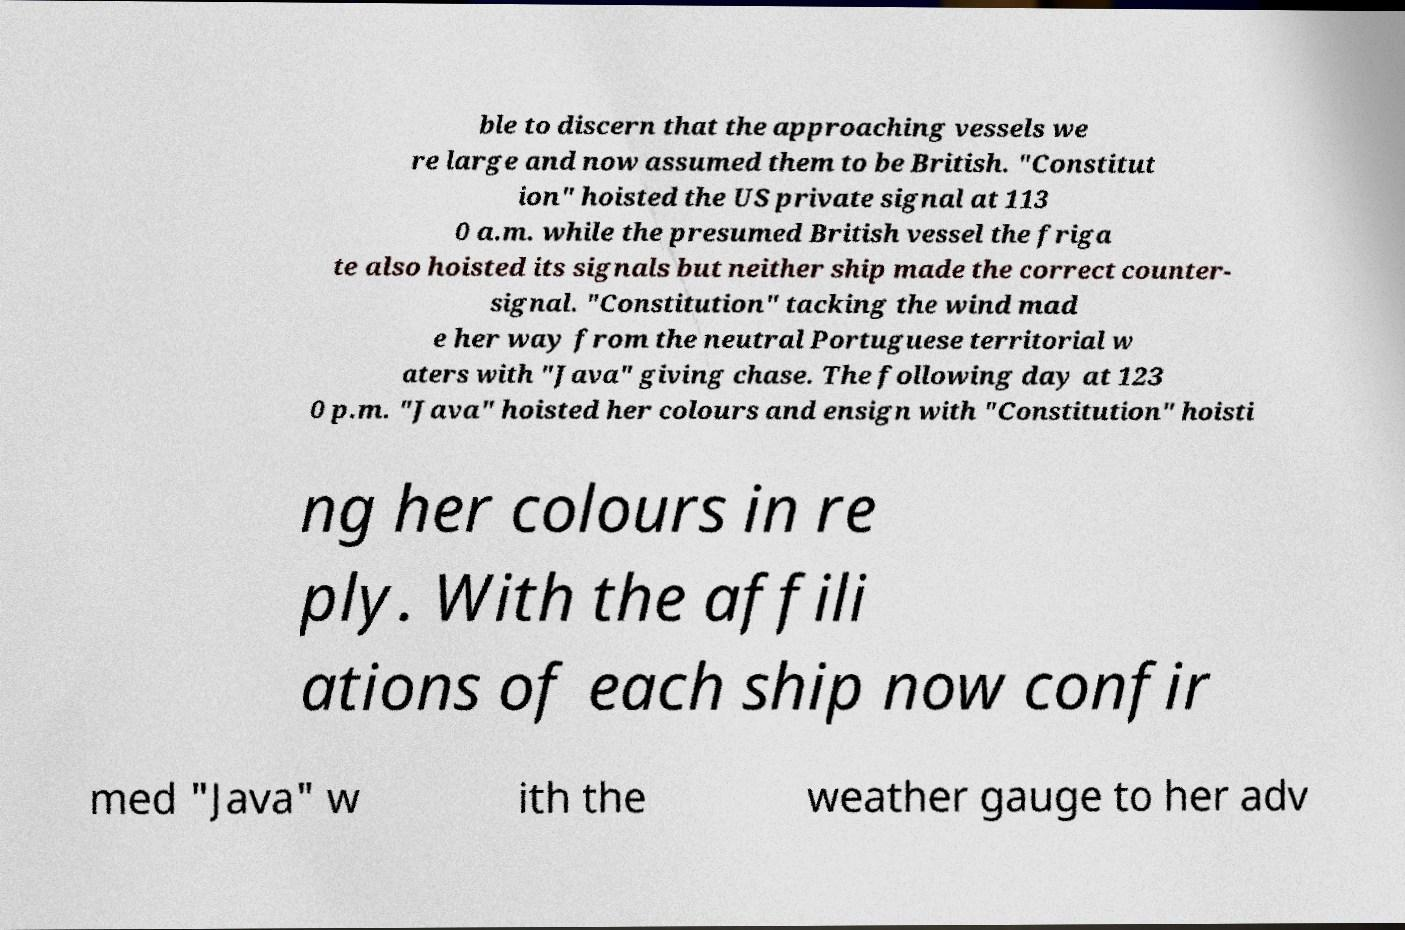Can you accurately transcribe the text from the provided image for me? ble to discern that the approaching vessels we re large and now assumed them to be British. "Constitut ion" hoisted the US private signal at 113 0 a.m. while the presumed British vessel the friga te also hoisted its signals but neither ship made the correct counter- signal. "Constitution" tacking the wind mad e her way from the neutral Portuguese territorial w aters with "Java" giving chase. The following day at 123 0 p.m. "Java" hoisted her colours and ensign with "Constitution" hoisti ng her colours in re ply. With the affili ations of each ship now confir med "Java" w ith the weather gauge to her adv 